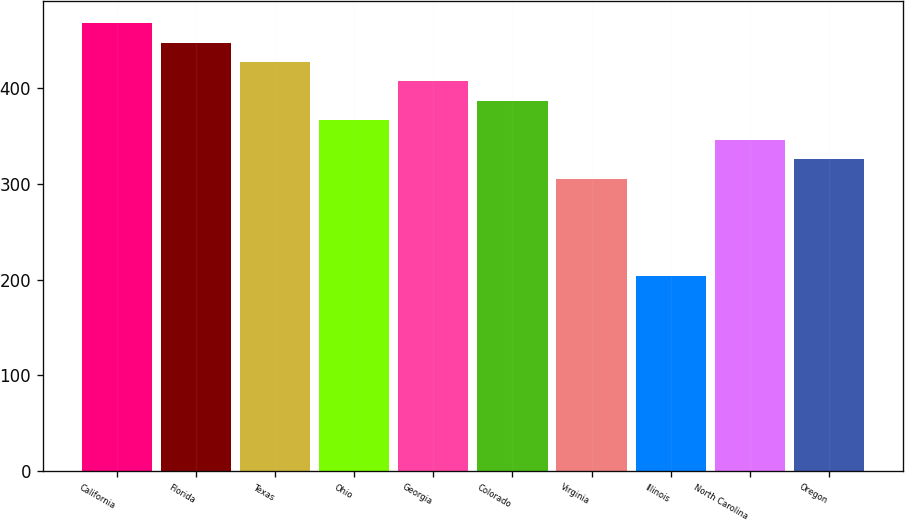Convert chart to OTSL. <chart><loc_0><loc_0><loc_500><loc_500><bar_chart><fcel>California<fcel>Florida<fcel>Texas<fcel>Ohio<fcel>Georgia<fcel>Colorado<fcel>Virginia<fcel>Illinois<fcel>North Carolina<fcel>Oregon<nl><fcel>467.9<fcel>447.6<fcel>427.3<fcel>366.4<fcel>407<fcel>386.7<fcel>305.5<fcel>204<fcel>346.1<fcel>325.8<nl></chart> 